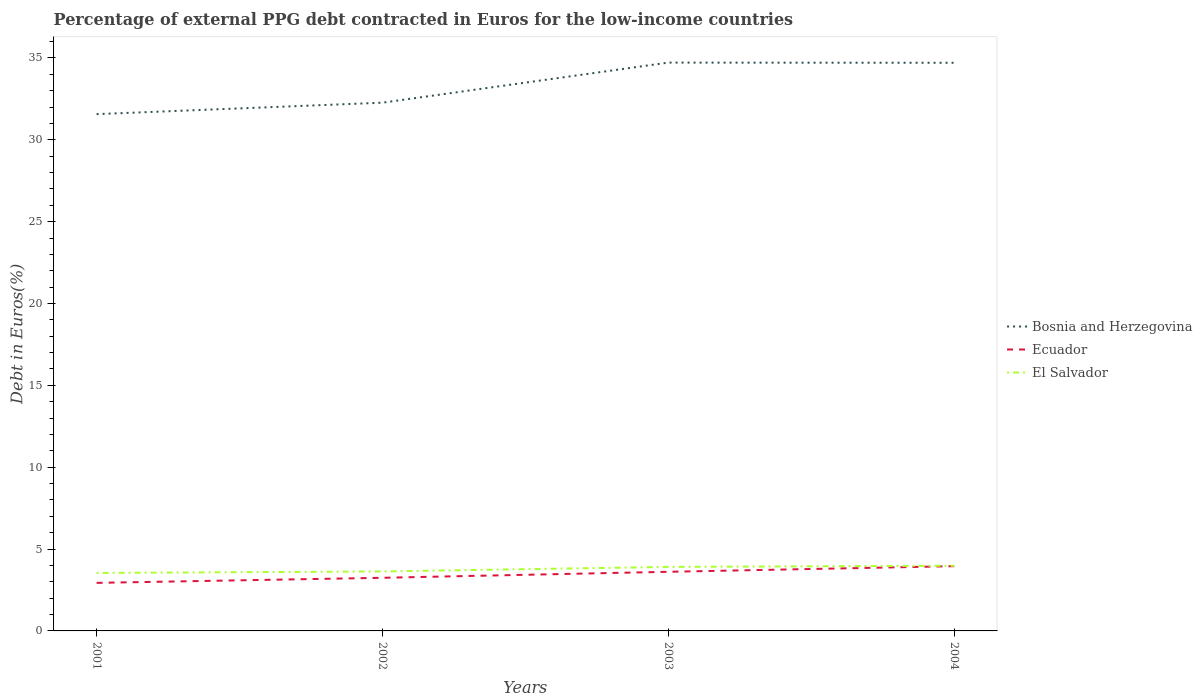How many different coloured lines are there?
Ensure brevity in your answer.  3. Does the line corresponding to Bosnia and Herzegovina intersect with the line corresponding to Ecuador?
Provide a short and direct response. No. Is the number of lines equal to the number of legend labels?
Offer a terse response. Yes. Across all years, what is the maximum percentage of external PPG debt contracted in Euros in El Salvador?
Provide a succinct answer. 3.54. In which year was the percentage of external PPG debt contracted in Euros in Bosnia and Herzegovina maximum?
Give a very brief answer. 2001. What is the total percentage of external PPG debt contracted in Euros in El Salvador in the graph?
Your answer should be compact. -0.37. What is the difference between the highest and the second highest percentage of external PPG debt contracted in Euros in Bosnia and Herzegovina?
Make the answer very short. 3.15. What is the difference between the highest and the lowest percentage of external PPG debt contracted in Euros in El Salvador?
Your answer should be very brief. 2. Is the percentage of external PPG debt contracted in Euros in Bosnia and Herzegovina strictly greater than the percentage of external PPG debt contracted in Euros in El Salvador over the years?
Keep it short and to the point. No. How are the legend labels stacked?
Provide a succinct answer. Vertical. What is the title of the graph?
Offer a very short reply. Percentage of external PPG debt contracted in Euros for the low-income countries. Does "El Salvador" appear as one of the legend labels in the graph?
Give a very brief answer. Yes. What is the label or title of the X-axis?
Offer a terse response. Years. What is the label or title of the Y-axis?
Provide a short and direct response. Debt in Euros(%). What is the Debt in Euros(%) of Bosnia and Herzegovina in 2001?
Ensure brevity in your answer.  31.57. What is the Debt in Euros(%) of Ecuador in 2001?
Your response must be concise. 2.94. What is the Debt in Euros(%) of El Salvador in 2001?
Provide a succinct answer. 3.54. What is the Debt in Euros(%) of Bosnia and Herzegovina in 2002?
Keep it short and to the point. 32.27. What is the Debt in Euros(%) of Ecuador in 2002?
Your answer should be compact. 3.25. What is the Debt in Euros(%) in El Salvador in 2002?
Provide a short and direct response. 3.63. What is the Debt in Euros(%) in Bosnia and Herzegovina in 2003?
Provide a succinct answer. 34.72. What is the Debt in Euros(%) of Ecuador in 2003?
Your answer should be compact. 3.61. What is the Debt in Euros(%) of El Salvador in 2003?
Provide a succinct answer. 3.91. What is the Debt in Euros(%) in Bosnia and Herzegovina in 2004?
Offer a terse response. 34.71. What is the Debt in Euros(%) of Ecuador in 2004?
Ensure brevity in your answer.  3.96. What is the Debt in Euros(%) of El Salvador in 2004?
Give a very brief answer. 3.98. Across all years, what is the maximum Debt in Euros(%) in Bosnia and Herzegovina?
Your answer should be compact. 34.72. Across all years, what is the maximum Debt in Euros(%) in Ecuador?
Give a very brief answer. 3.96. Across all years, what is the maximum Debt in Euros(%) in El Salvador?
Provide a succinct answer. 3.98. Across all years, what is the minimum Debt in Euros(%) in Bosnia and Herzegovina?
Your response must be concise. 31.57. Across all years, what is the minimum Debt in Euros(%) of Ecuador?
Provide a short and direct response. 2.94. Across all years, what is the minimum Debt in Euros(%) of El Salvador?
Offer a terse response. 3.54. What is the total Debt in Euros(%) in Bosnia and Herzegovina in the graph?
Keep it short and to the point. 133.26. What is the total Debt in Euros(%) of Ecuador in the graph?
Your answer should be compact. 13.75. What is the total Debt in Euros(%) in El Salvador in the graph?
Keep it short and to the point. 15.07. What is the difference between the Debt in Euros(%) of Bosnia and Herzegovina in 2001 and that in 2002?
Keep it short and to the point. -0.7. What is the difference between the Debt in Euros(%) of Ecuador in 2001 and that in 2002?
Ensure brevity in your answer.  -0.31. What is the difference between the Debt in Euros(%) of El Salvador in 2001 and that in 2002?
Make the answer very short. -0.09. What is the difference between the Debt in Euros(%) in Bosnia and Herzegovina in 2001 and that in 2003?
Provide a succinct answer. -3.15. What is the difference between the Debt in Euros(%) of Ecuador in 2001 and that in 2003?
Offer a terse response. -0.68. What is the difference between the Debt in Euros(%) in El Salvador in 2001 and that in 2003?
Ensure brevity in your answer.  -0.37. What is the difference between the Debt in Euros(%) of Bosnia and Herzegovina in 2001 and that in 2004?
Offer a terse response. -3.14. What is the difference between the Debt in Euros(%) in Ecuador in 2001 and that in 2004?
Your answer should be compact. -1.02. What is the difference between the Debt in Euros(%) of El Salvador in 2001 and that in 2004?
Your answer should be compact. -0.44. What is the difference between the Debt in Euros(%) of Bosnia and Herzegovina in 2002 and that in 2003?
Make the answer very short. -2.45. What is the difference between the Debt in Euros(%) in Ecuador in 2002 and that in 2003?
Provide a short and direct response. -0.37. What is the difference between the Debt in Euros(%) in El Salvador in 2002 and that in 2003?
Your answer should be compact. -0.28. What is the difference between the Debt in Euros(%) of Bosnia and Herzegovina in 2002 and that in 2004?
Provide a short and direct response. -2.44. What is the difference between the Debt in Euros(%) of Ecuador in 2002 and that in 2004?
Offer a terse response. -0.71. What is the difference between the Debt in Euros(%) in El Salvador in 2002 and that in 2004?
Your answer should be compact. -0.35. What is the difference between the Debt in Euros(%) of Bosnia and Herzegovina in 2003 and that in 2004?
Your answer should be compact. 0.01. What is the difference between the Debt in Euros(%) of Ecuador in 2003 and that in 2004?
Make the answer very short. -0.34. What is the difference between the Debt in Euros(%) of El Salvador in 2003 and that in 2004?
Offer a terse response. -0.07. What is the difference between the Debt in Euros(%) of Bosnia and Herzegovina in 2001 and the Debt in Euros(%) of Ecuador in 2002?
Your answer should be compact. 28.32. What is the difference between the Debt in Euros(%) of Bosnia and Herzegovina in 2001 and the Debt in Euros(%) of El Salvador in 2002?
Provide a short and direct response. 27.94. What is the difference between the Debt in Euros(%) of Ecuador in 2001 and the Debt in Euros(%) of El Salvador in 2002?
Provide a short and direct response. -0.7. What is the difference between the Debt in Euros(%) of Bosnia and Herzegovina in 2001 and the Debt in Euros(%) of Ecuador in 2003?
Ensure brevity in your answer.  27.96. What is the difference between the Debt in Euros(%) of Bosnia and Herzegovina in 2001 and the Debt in Euros(%) of El Salvador in 2003?
Give a very brief answer. 27.66. What is the difference between the Debt in Euros(%) of Ecuador in 2001 and the Debt in Euros(%) of El Salvador in 2003?
Give a very brief answer. -0.98. What is the difference between the Debt in Euros(%) in Bosnia and Herzegovina in 2001 and the Debt in Euros(%) in Ecuador in 2004?
Your answer should be compact. 27.61. What is the difference between the Debt in Euros(%) of Bosnia and Herzegovina in 2001 and the Debt in Euros(%) of El Salvador in 2004?
Provide a succinct answer. 27.59. What is the difference between the Debt in Euros(%) of Ecuador in 2001 and the Debt in Euros(%) of El Salvador in 2004?
Your answer should be compact. -1.05. What is the difference between the Debt in Euros(%) in Bosnia and Herzegovina in 2002 and the Debt in Euros(%) in Ecuador in 2003?
Offer a very short reply. 28.66. What is the difference between the Debt in Euros(%) of Bosnia and Herzegovina in 2002 and the Debt in Euros(%) of El Salvador in 2003?
Ensure brevity in your answer.  28.36. What is the difference between the Debt in Euros(%) in Ecuador in 2002 and the Debt in Euros(%) in El Salvador in 2003?
Keep it short and to the point. -0.67. What is the difference between the Debt in Euros(%) of Bosnia and Herzegovina in 2002 and the Debt in Euros(%) of Ecuador in 2004?
Provide a short and direct response. 28.31. What is the difference between the Debt in Euros(%) of Bosnia and Herzegovina in 2002 and the Debt in Euros(%) of El Salvador in 2004?
Your answer should be compact. 28.29. What is the difference between the Debt in Euros(%) in Ecuador in 2002 and the Debt in Euros(%) in El Salvador in 2004?
Offer a terse response. -0.74. What is the difference between the Debt in Euros(%) of Bosnia and Herzegovina in 2003 and the Debt in Euros(%) of Ecuador in 2004?
Offer a terse response. 30.76. What is the difference between the Debt in Euros(%) in Bosnia and Herzegovina in 2003 and the Debt in Euros(%) in El Salvador in 2004?
Keep it short and to the point. 30.73. What is the difference between the Debt in Euros(%) in Ecuador in 2003 and the Debt in Euros(%) in El Salvador in 2004?
Offer a very short reply. -0.37. What is the average Debt in Euros(%) of Bosnia and Herzegovina per year?
Ensure brevity in your answer.  33.31. What is the average Debt in Euros(%) of Ecuador per year?
Keep it short and to the point. 3.44. What is the average Debt in Euros(%) of El Salvador per year?
Offer a terse response. 3.77. In the year 2001, what is the difference between the Debt in Euros(%) of Bosnia and Herzegovina and Debt in Euros(%) of Ecuador?
Offer a terse response. 28.63. In the year 2001, what is the difference between the Debt in Euros(%) of Bosnia and Herzegovina and Debt in Euros(%) of El Salvador?
Make the answer very short. 28.03. In the year 2001, what is the difference between the Debt in Euros(%) in Ecuador and Debt in Euros(%) in El Salvador?
Give a very brief answer. -0.61. In the year 2002, what is the difference between the Debt in Euros(%) in Bosnia and Herzegovina and Debt in Euros(%) in Ecuador?
Provide a succinct answer. 29.02. In the year 2002, what is the difference between the Debt in Euros(%) of Bosnia and Herzegovina and Debt in Euros(%) of El Salvador?
Provide a short and direct response. 28.64. In the year 2002, what is the difference between the Debt in Euros(%) of Ecuador and Debt in Euros(%) of El Salvador?
Give a very brief answer. -0.39. In the year 2003, what is the difference between the Debt in Euros(%) of Bosnia and Herzegovina and Debt in Euros(%) of Ecuador?
Give a very brief answer. 31.11. In the year 2003, what is the difference between the Debt in Euros(%) of Bosnia and Herzegovina and Debt in Euros(%) of El Salvador?
Keep it short and to the point. 30.81. In the year 2003, what is the difference between the Debt in Euros(%) of Ecuador and Debt in Euros(%) of El Salvador?
Make the answer very short. -0.3. In the year 2004, what is the difference between the Debt in Euros(%) in Bosnia and Herzegovina and Debt in Euros(%) in Ecuador?
Make the answer very short. 30.75. In the year 2004, what is the difference between the Debt in Euros(%) of Bosnia and Herzegovina and Debt in Euros(%) of El Salvador?
Offer a very short reply. 30.72. In the year 2004, what is the difference between the Debt in Euros(%) of Ecuador and Debt in Euros(%) of El Salvador?
Offer a very short reply. -0.03. What is the ratio of the Debt in Euros(%) of Bosnia and Herzegovina in 2001 to that in 2002?
Your answer should be very brief. 0.98. What is the ratio of the Debt in Euros(%) in Ecuador in 2001 to that in 2002?
Your answer should be very brief. 0.9. What is the ratio of the Debt in Euros(%) in El Salvador in 2001 to that in 2002?
Keep it short and to the point. 0.97. What is the ratio of the Debt in Euros(%) in Bosnia and Herzegovina in 2001 to that in 2003?
Give a very brief answer. 0.91. What is the ratio of the Debt in Euros(%) in Ecuador in 2001 to that in 2003?
Provide a succinct answer. 0.81. What is the ratio of the Debt in Euros(%) in El Salvador in 2001 to that in 2003?
Provide a short and direct response. 0.91. What is the ratio of the Debt in Euros(%) in Bosnia and Herzegovina in 2001 to that in 2004?
Your response must be concise. 0.91. What is the ratio of the Debt in Euros(%) in Ecuador in 2001 to that in 2004?
Ensure brevity in your answer.  0.74. What is the ratio of the Debt in Euros(%) of El Salvador in 2001 to that in 2004?
Offer a very short reply. 0.89. What is the ratio of the Debt in Euros(%) in Bosnia and Herzegovina in 2002 to that in 2003?
Ensure brevity in your answer.  0.93. What is the ratio of the Debt in Euros(%) in Ecuador in 2002 to that in 2003?
Make the answer very short. 0.9. What is the ratio of the Debt in Euros(%) of El Salvador in 2002 to that in 2003?
Provide a short and direct response. 0.93. What is the ratio of the Debt in Euros(%) in Bosnia and Herzegovina in 2002 to that in 2004?
Make the answer very short. 0.93. What is the ratio of the Debt in Euros(%) of Ecuador in 2002 to that in 2004?
Offer a very short reply. 0.82. What is the ratio of the Debt in Euros(%) of El Salvador in 2002 to that in 2004?
Provide a short and direct response. 0.91. What is the ratio of the Debt in Euros(%) of Bosnia and Herzegovina in 2003 to that in 2004?
Keep it short and to the point. 1. What is the ratio of the Debt in Euros(%) of Ecuador in 2003 to that in 2004?
Ensure brevity in your answer.  0.91. What is the ratio of the Debt in Euros(%) in El Salvador in 2003 to that in 2004?
Give a very brief answer. 0.98. What is the difference between the highest and the second highest Debt in Euros(%) of Bosnia and Herzegovina?
Keep it short and to the point. 0.01. What is the difference between the highest and the second highest Debt in Euros(%) in Ecuador?
Offer a very short reply. 0.34. What is the difference between the highest and the second highest Debt in Euros(%) in El Salvador?
Ensure brevity in your answer.  0.07. What is the difference between the highest and the lowest Debt in Euros(%) in Bosnia and Herzegovina?
Your response must be concise. 3.15. What is the difference between the highest and the lowest Debt in Euros(%) in Ecuador?
Your answer should be very brief. 1.02. What is the difference between the highest and the lowest Debt in Euros(%) of El Salvador?
Offer a very short reply. 0.44. 